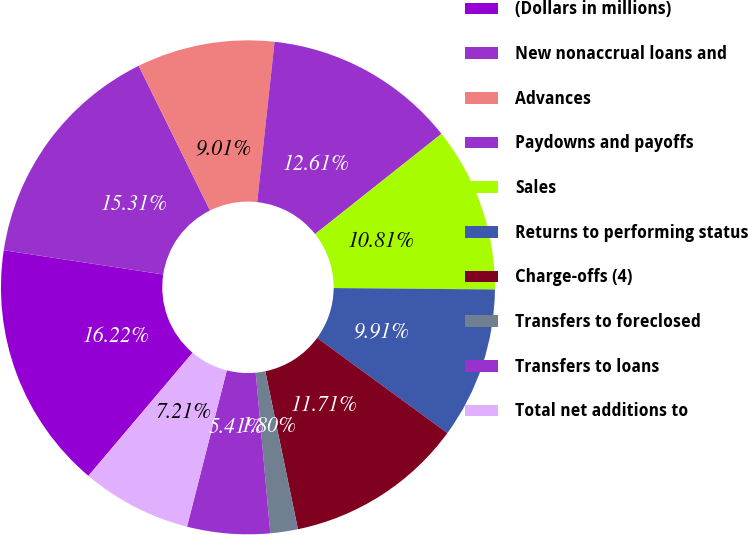Convert chart to OTSL. <chart><loc_0><loc_0><loc_500><loc_500><pie_chart><fcel>(Dollars in millions)<fcel>New nonaccrual loans and<fcel>Advances<fcel>Paydowns and payoffs<fcel>Sales<fcel>Returns to performing status<fcel>Charge-offs (4)<fcel>Transfers to foreclosed<fcel>Transfers to loans<fcel>Total net additions to<nl><fcel>16.22%<fcel>15.31%<fcel>9.01%<fcel>12.61%<fcel>10.81%<fcel>9.91%<fcel>11.71%<fcel>1.8%<fcel>5.41%<fcel>7.21%<nl></chart> 